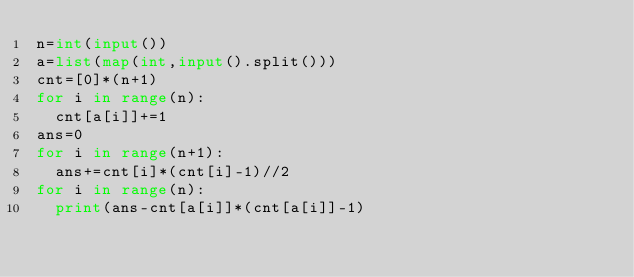<code> <loc_0><loc_0><loc_500><loc_500><_Python_>n=int(input())
a=list(map(int,input().split()))
cnt=[0]*(n+1)
for i in range(n):
  cnt[a[i]]+=1
ans=0
for i in range(n+1):
  ans+=cnt[i]*(cnt[i]-1)//2
for i in range(n):
  print(ans-cnt[a[i]]*(cnt[a[i]]-1)</code> 